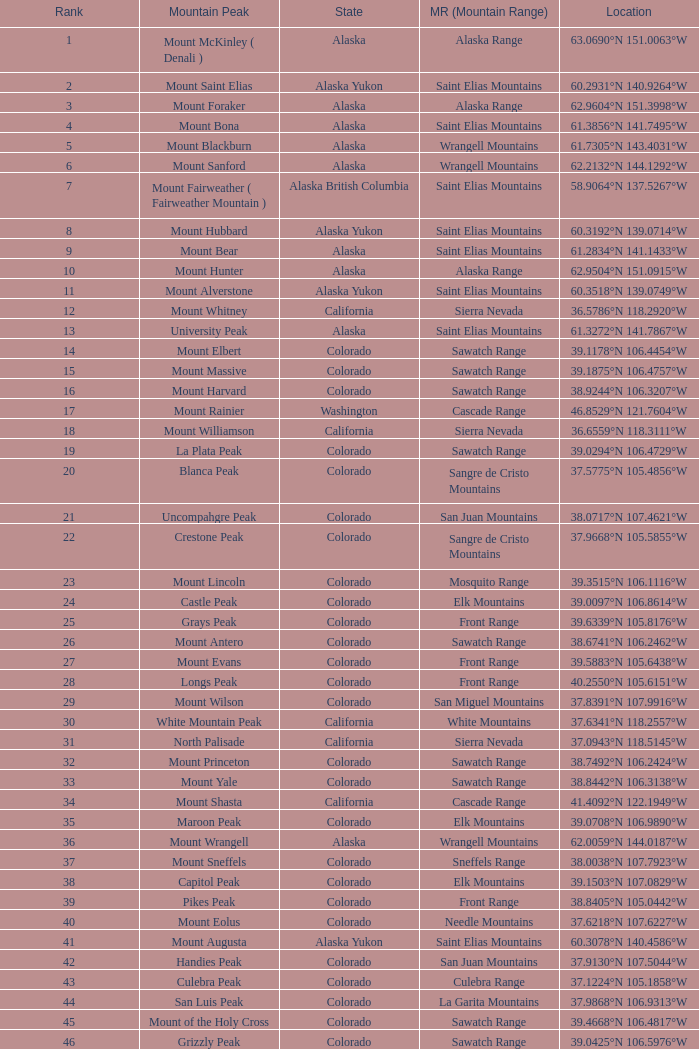What is the mountain peak when the location is 37.5775°n 105.4856°w? Blanca Peak. 